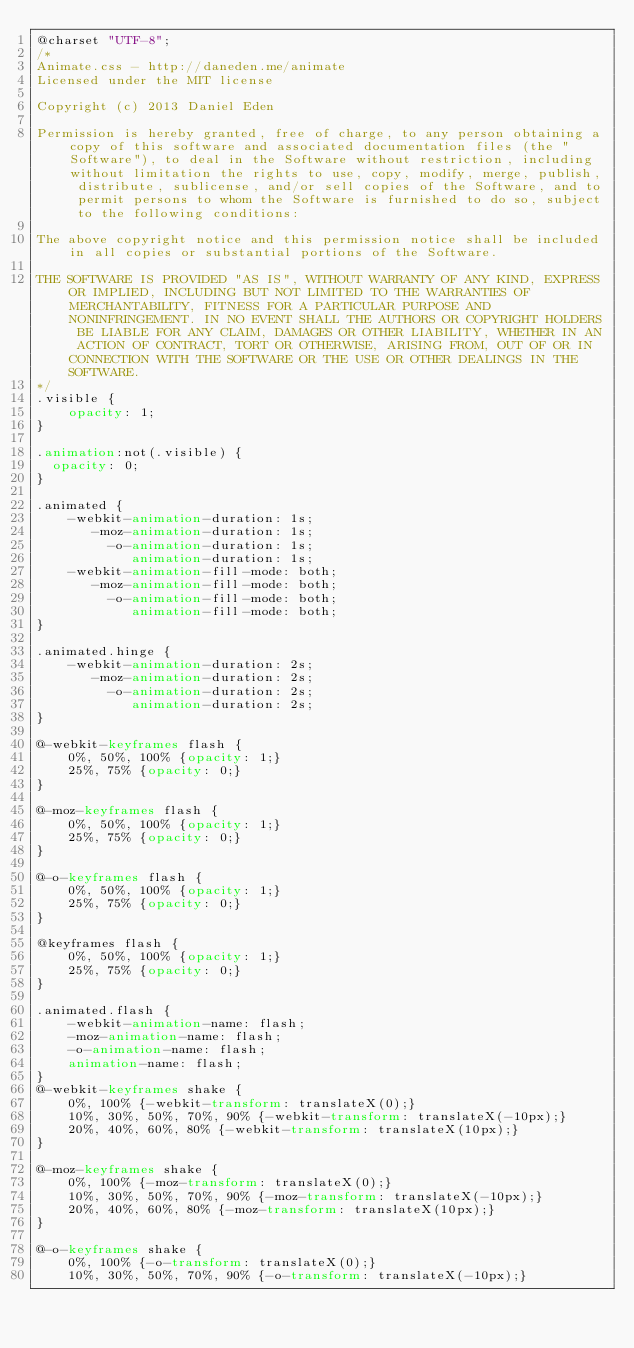Convert code to text. <code><loc_0><loc_0><loc_500><loc_500><_CSS_>@charset "UTF-8";
/*
Animate.css - http://daneden.me/animate
Licensed under the MIT license

Copyright (c) 2013 Daniel Eden

Permission is hereby granted, free of charge, to any person obtaining a copy of this software and associated documentation files (the "Software"), to deal in the Software without restriction, including without limitation the rights to use, copy, modify, merge, publish, distribute, sublicense, and/or sell copies of the Software, and to permit persons to whom the Software is furnished to do so, subject to the following conditions:

The above copyright notice and this permission notice shall be included in all copies or substantial portions of the Software.

THE SOFTWARE IS PROVIDED "AS IS", WITHOUT WARRANTY OF ANY KIND, EXPRESS OR IMPLIED, INCLUDING BUT NOT LIMITED TO THE WARRANTIES OF MERCHANTABILITY, FITNESS FOR A PARTICULAR PURPOSE AND NONINFRINGEMENT. IN NO EVENT SHALL THE AUTHORS OR COPYRIGHT HOLDERS BE LIABLE FOR ANY CLAIM, DAMAGES OR OTHER LIABILITY, WHETHER IN AN ACTION OF CONTRACT, TORT OR OTHERWISE, ARISING FROM, OUT OF OR IN CONNECTION WITH THE SOFTWARE OR THE USE OR OTHER DEALINGS IN THE SOFTWARE.
*/
.visible {
	opacity: 1;
}

.animation:not(.visible) {
  opacity: 0;
}

.animated {
	-webkit-animation-duration: 1s;
	   -moz-animation-duration: 1s;
	     -o-animation-duration: 1s;
	        animation-duration: 1s;
	-webkit-animation-fill-mode: both;
	   -moz-animation-fill-mode: both;
	     -o-animation-fill-mode: both;
	        animation-fill-mode: both;
}

.animated.hinge {
	-webkit-animation-duration: 2s;
	   -moz-animation-duration: 2s;
	     -o-animation-duration: 2s;
	        animation-duration: 2s;
}

@-webkit-keyframes flash {
	0%, 50%, 100% {opacity: 1;}
	25%, 75% {opacity: 0;}
}

@-moz-keyframes flash {
	0%, 50%, 100% {opacity: 1;}
	25%, 75% {opacity: 0;}
}

@-o-keyframes flash {
	0%, 50%, 100% {opacity: 1;}
	25%, 75% {opacity: 0;}
}

@keyframes flash {
	0%, 50%, 100% {opacity: 1;}
	25%, 75% {opacity: 0;}
}

.animated.flash {
	-webkit-animation-name: flash;
	-moz-animation-name: flash;
	-o-animation-name: flash;
	animation-name: flash;
}
@-webkit-keyframes shake {
	0%, 100% {-webkit-transform: translateX(0);}
	10%, 30%, 50%, 70%, 90% {-webkit-transform: translateX(-10px);}
	20%, 40%, 60%, 80% {-webkit-transform: translateX(10px);}
}

@-moz-keyframes shake {
	0%, 100% {-moz-transform: translateX(0);}
	10%, 30%, 50%, 70%, 90% {-moz-transform: translateX(-10px);}
	20%, 40%, 60%, 80% {-moz-transform: translateX(10px);}
}

@-o-keyframes shake {
	0%, 100% {-o-transform: translateX(0);}
	10%, 30%, 50%, 70%, 90% {-o-transform: translateX(-10px);}</code> 